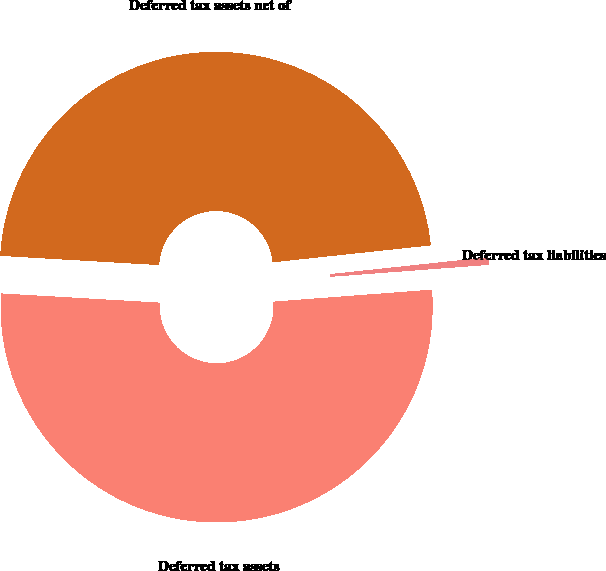Convert chart to OTSL. <chart><loc_0><loc_0><loc_500><loc_500><pie_chart><fcel>Deferred tax assets<fcel>Deferred tax liabilities<fcel>Deferred tax assets net of<nl><fcel>52.12%<fcel>0.5%<fcel>47.38%<nl></chart> 